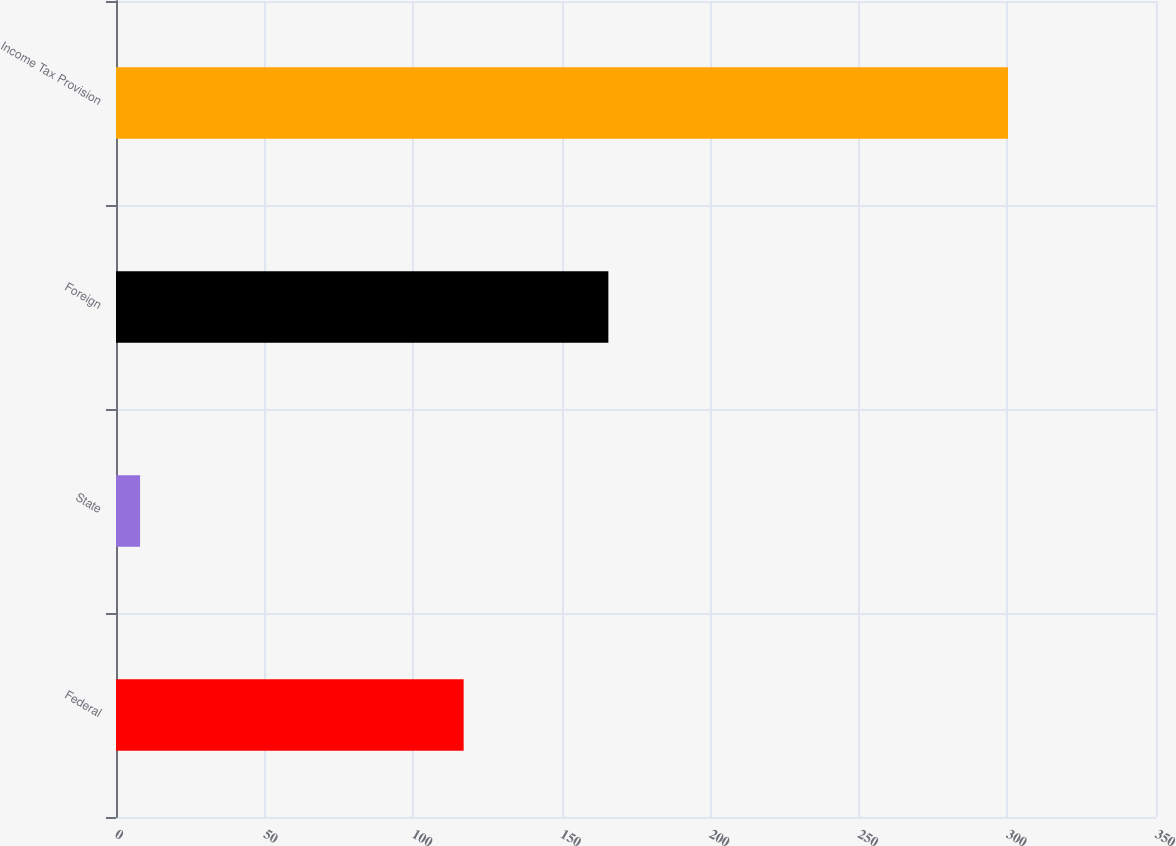<chart> <loc_0><loc_0><loc_500><loc_500><bar_chart><fcel>Federal<fcel>State<fcel>Foreign<fcel>Income Tax Provision<nl><fcel>117<fcel>8.1<fcel>165.7<fcel>300.2<nl></chart> 